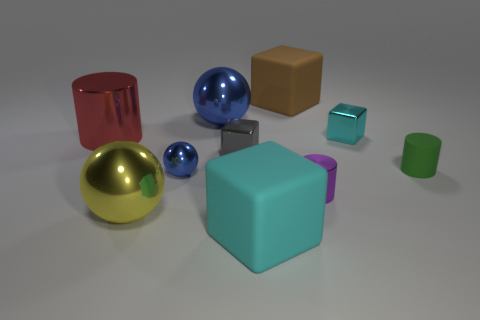Subtract all green balls. Subtract all cyan cylinders. How many balls are left? 3 Subtract all spheres. How many objects are left? 7 Subtract 1 blue balls. How many objects are left? 9 Subtract all purple shiny things. Subtract all metallic cylinders. How many objects are left? 7 Add 2 red cylinders. How many red cylinders are left? 3 Add 2 small cyan metal things. How many small cyan metal things exist? 3 